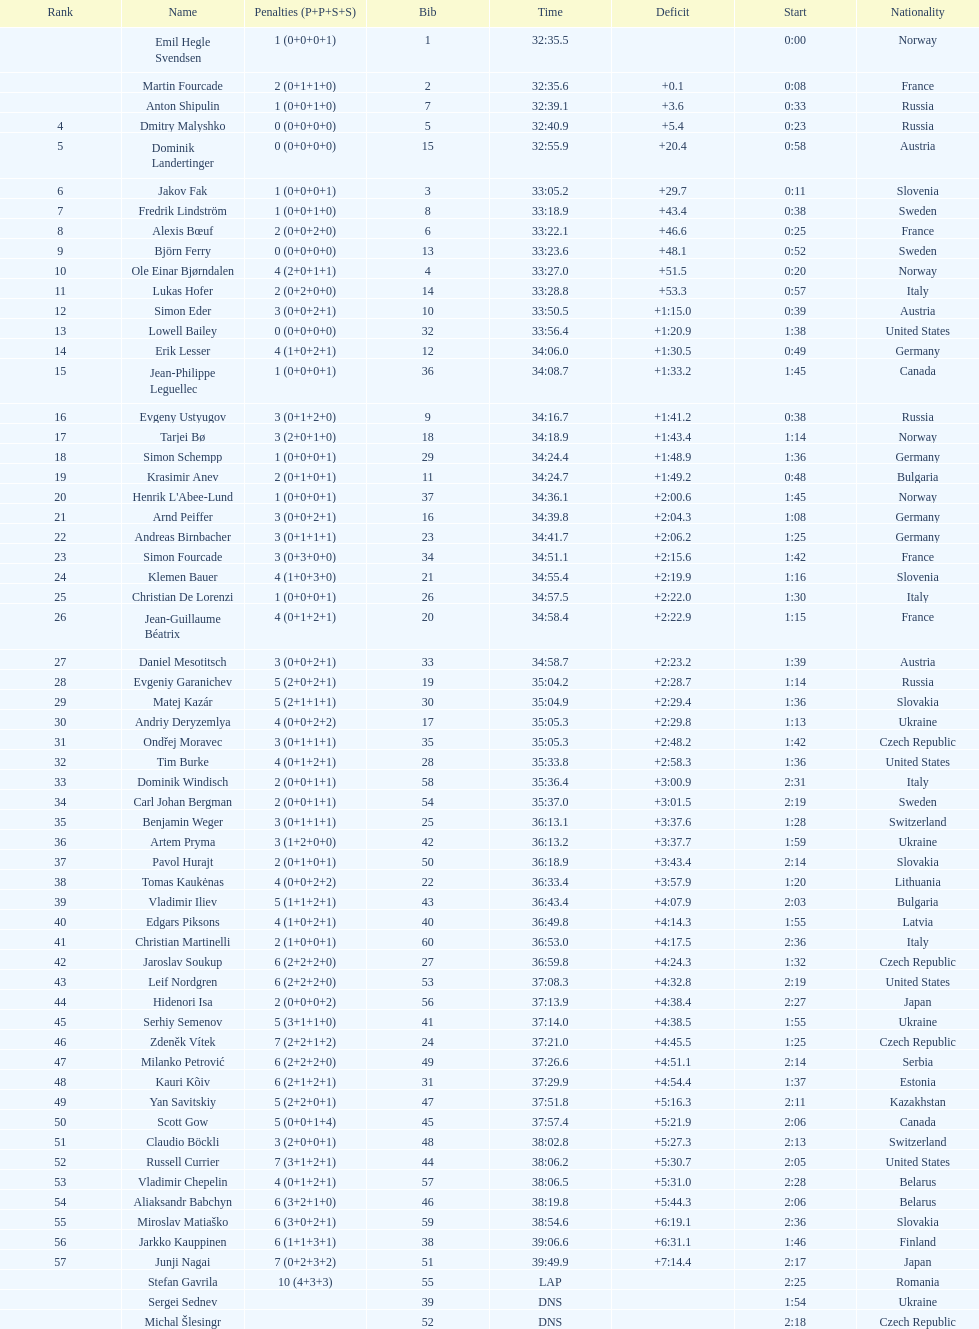In what amount of time did erik lesser complete? 34:06.0. 